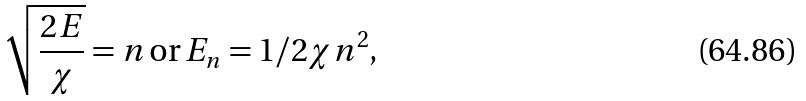Convert formula to latex. <formula><loc_0><loc_0><loc_500><loc_500>\sqrt { \frac { 2 E } { \chi } } = n \, \text {or} \, E _ { n } = 1 / 2 \chi n ^ { 2 } ,</formula> 